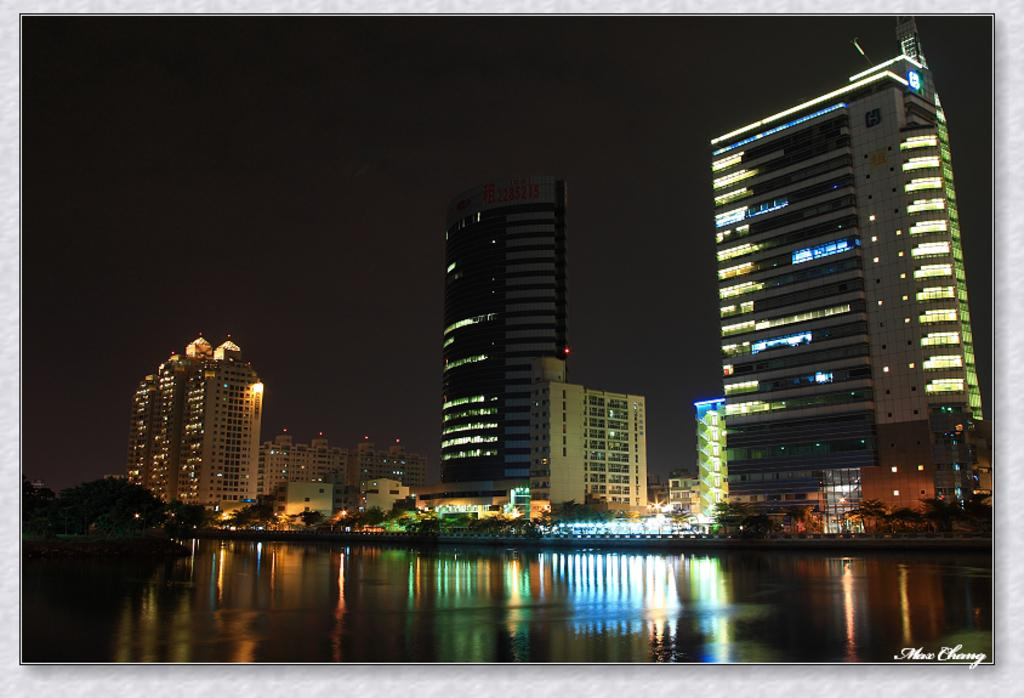What is the main feature of the image? The main feature of the image is a water surface. What can be seen behind the water surface? There are trees visible behind the water surface. What structures are present in the image? There are buildings with lights in the image. What is visible in the background of the image? The sky is visible in the background of the image. What type of feast is being prepared on the water surface in the image? There is no feast being prepared on the water surface in the image; it is a natural scene with a water surface, trees, buildings, and the sky. 